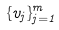Convert formula to latex. <formula><loc_0><loc_0><loc_500><loc_500>\{ v _ { j } \} _ { j = 1 } ^ { m }</formula> 